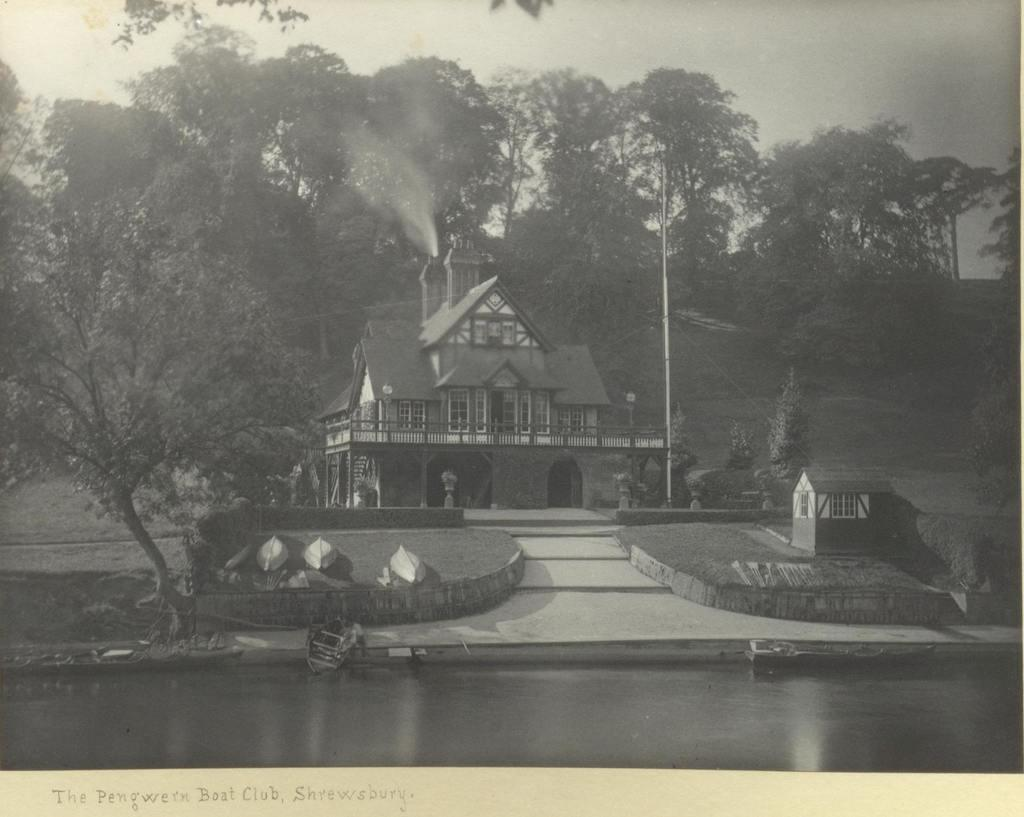What is the primary element visible in the image? There is water in the image. What type of natural vegetation can be seen in the image? There are trees in the image. What type of structure is present in the image? There is a house in the image. What color scheme is used in the image? The image is in black and white. How many baby gooses can be seen swimming in a circle in the image? There are no baby gooses or circles present in the image. 